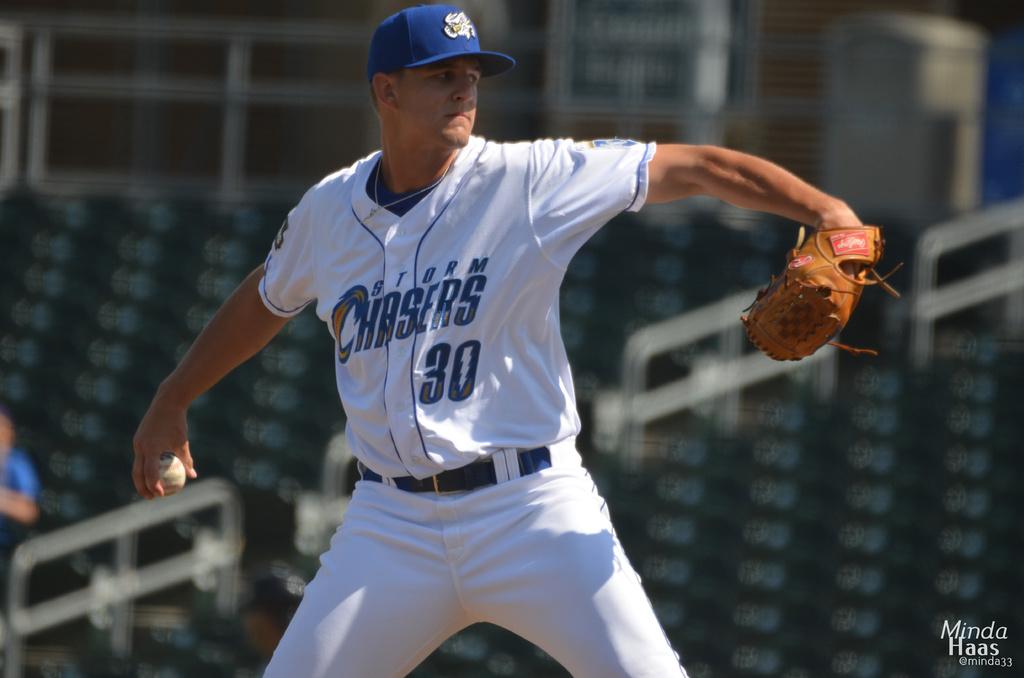What team does this pitcher play on?
Provide a short and direct response. Storm chasers. What number is the player?
Offer a terse response. 30. 